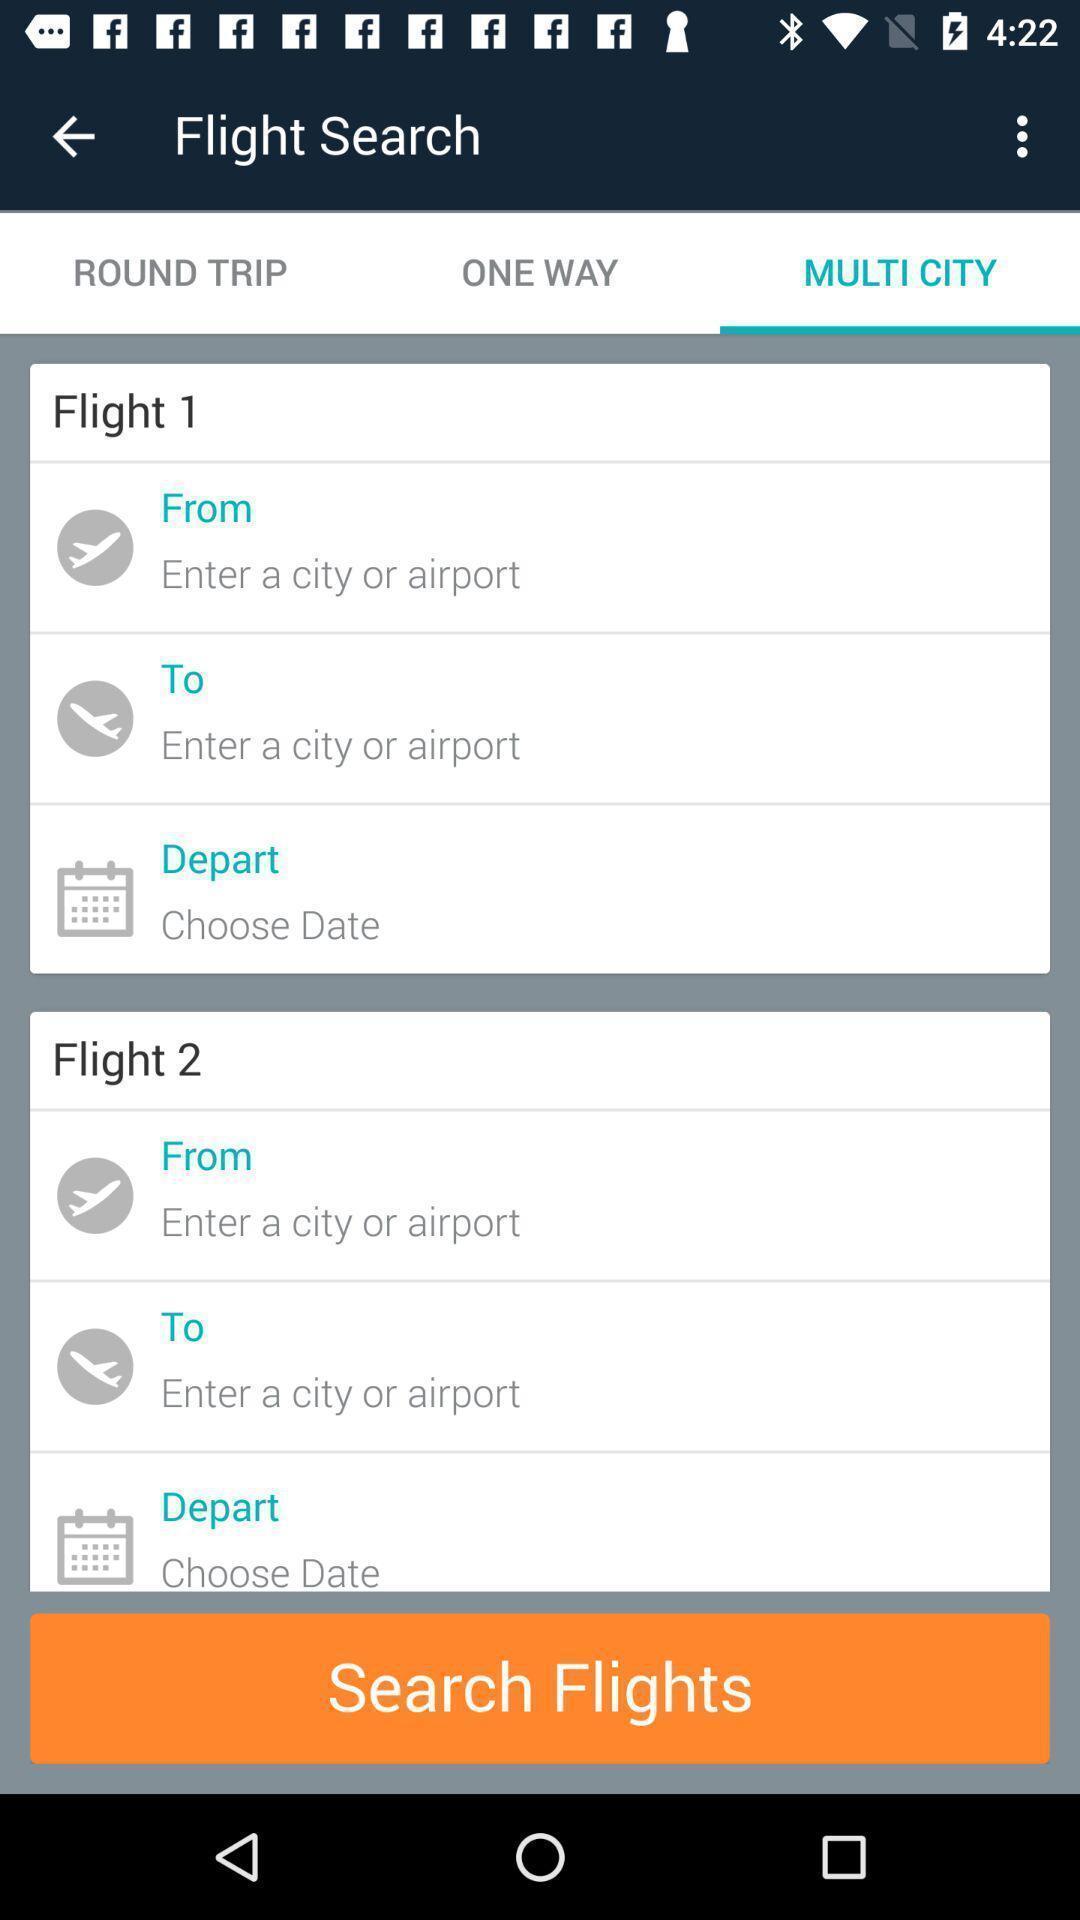Give me a summary of this screen capture. Page displaying to select the flights in an airlines app. 